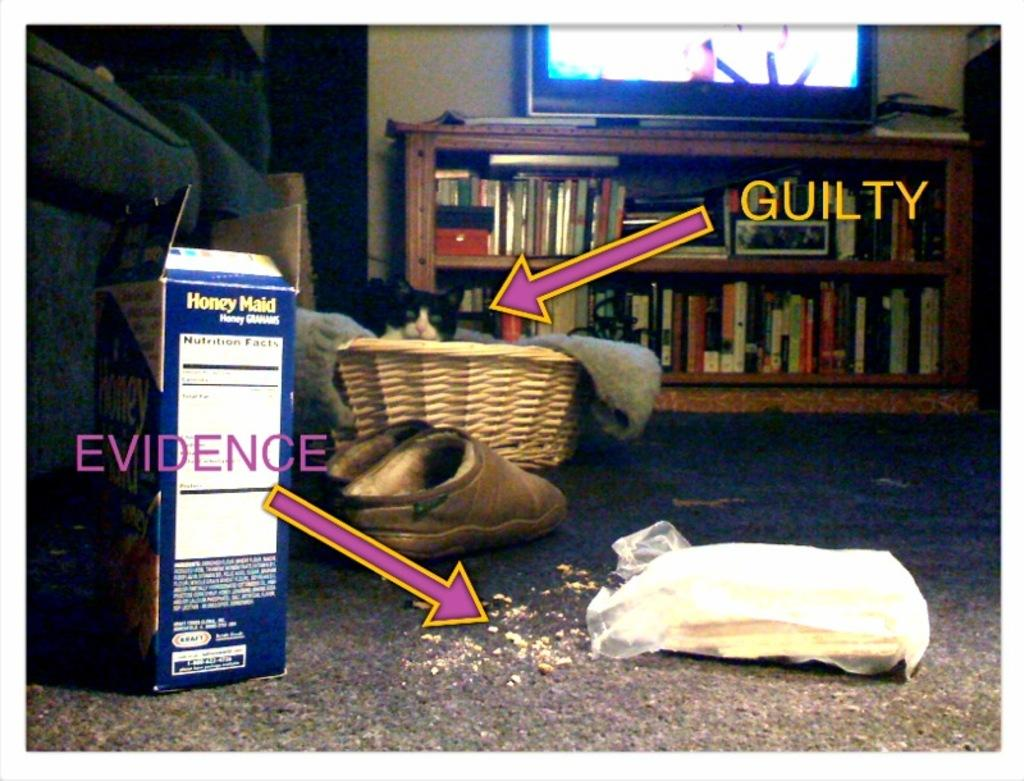<image>
Provide a brief description of the given image. the word guilty and evidence that are next to some items 